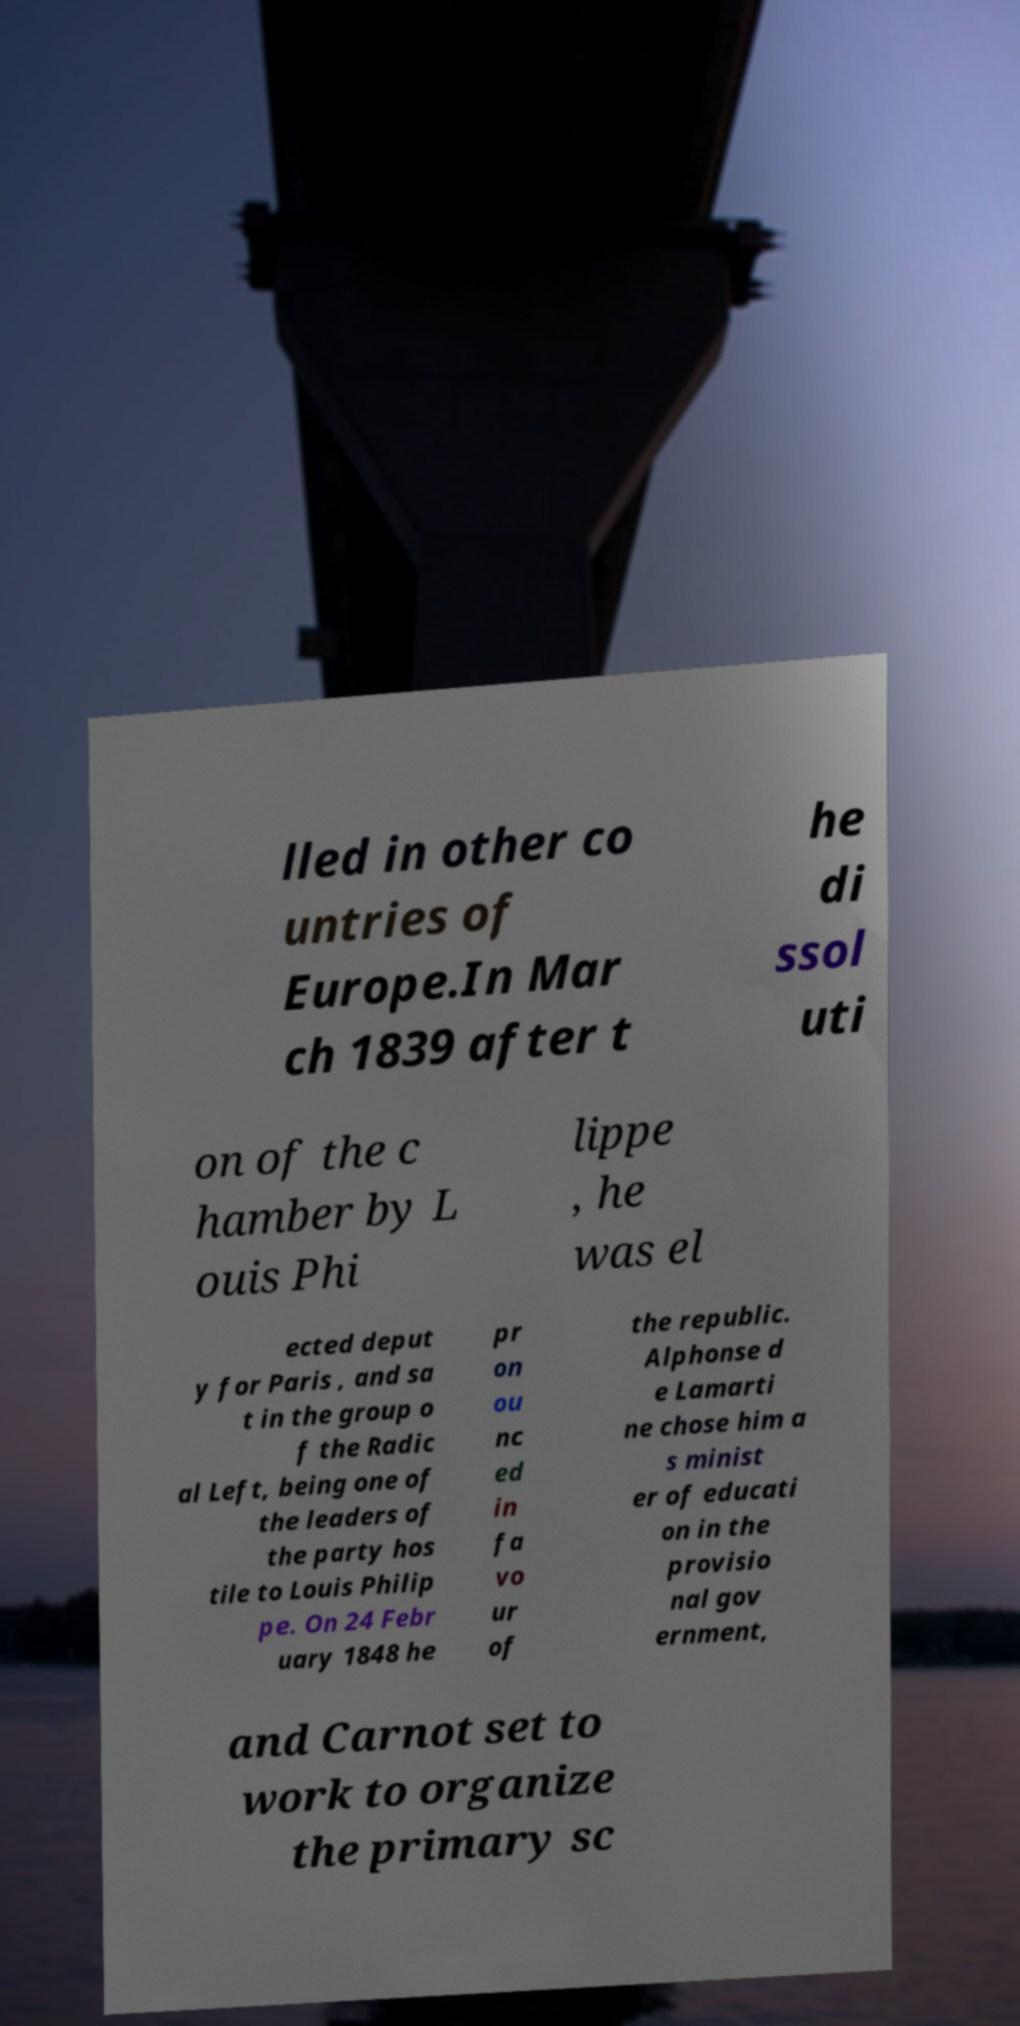Could you assist in decoding the text presented in this image and type it out clearly? lled in other co untries of Europe.In Mar ch 1839 after t he di ssol uti on of the c hamber by L ouis Phi lippe , he was el ected deput y for Paris , and sa t in the group o f the Radic al Left, being one of the leaders of the party hos tile to Louis Philip pe. On 24 Febr uary 1848 he pr on ou nc ed in fa vo ur of the republic. Alphonse d e Lamarti ne chose him a s minist er of educati on in the provisio nal gov ernment, and Carnot set to work to organize the primary sc 